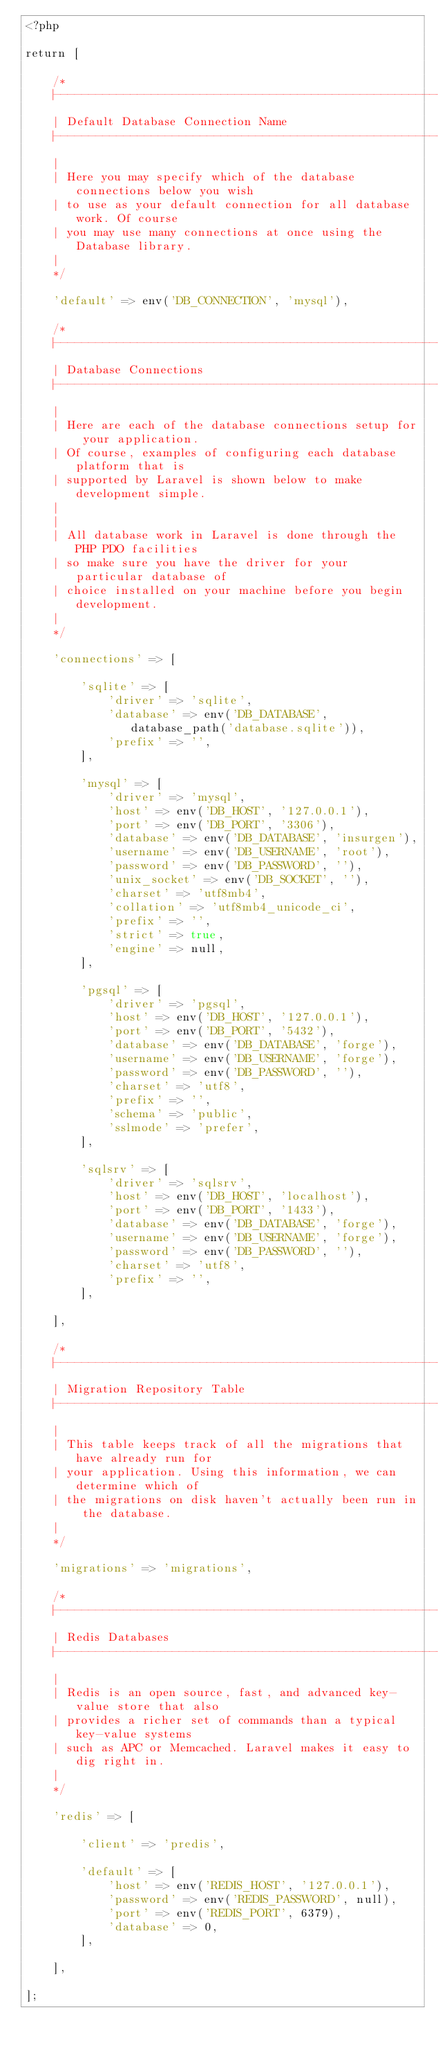Convert code to text. <code><loc_0><loc_0><loc_500><loc_500><_PHP_><?php

return [

    /*
    |--------------------------------------------------------------------------
    | Default Database Connection Name
    |--------------------------------------------------------------------------
    |
    | Here you may specify which of the database connections below you wish
    | to use as your default connection for all database work. Of course
    | you may use many connections at once using the Database library.
    |
    */

    'default' => env('DB_CONNECTION', 'mysql'),

    /*
    |--------------------------------------------------------------------------
    | Database Connections
    |--------------------------------------------------------------------------
    |
    | Here are each of the database connections setup for your application.
    | Of course, examples of configuring each database platform that is
    | supported by Laravel is shown below to make development simple.
    |
    |
    | All database work in Laravel is done through the PHP PDO facilities
    | so make sure you have the driver for your particular database of
    | choice installed on your machine before you begin development.
    |
    */

    'connections' => [

        'sqlite' => [
            'driver' => 'sqlite',
            'database' => env('DB_DATABASE', database_path('database.sqlite')),
            'prefix' => '',
        ],

        'mysql' => [
            'driver' => 'mysql',
            'host' => env('DB_HOST', '127.0.0.1'),
            'port' => env('DB_PORT', '3306'),
            'database' => env('DB_DATABASE', 'insurgen'),
            'username' => env('DB_USERNAME', 'root'),
            'password' => env('DB_PASSWORD', ''),
            'unix_socket' => env('DB_SOCKET', ''),
            'charset' => 'utf8mb4',
            'collation' => 'utf8mb4_unicode_ci',
            'prefix' => '',
            'strict' => true,
            'engine' => null,
        ],

        'pgsql' => [
            'driver' => 'pgsql',
            'host' => env('DB_HOST', '127.0.0.1'),
            'port' => env('DB_PORT', '5432'),
            'database' => env('DB_DATABASE', 'forge'),
            'username' => env('DB_USERNAME', 'forge'),
            'password' => env('DB_PASSWORD', ''),
            'charset' => 'utf8',
            'prefix' => '',
            'schema' => 'public',
            'sslmode' => 'prefer',
        ],

        'sqlsrv' => [
            'driver' => 'sqlsrv',
            'host' => env('DB_HOST', 'localhost'),
            'port' => env('DB_PORT', '1433'),
            'database' => env('DB_DATABASE', 'forge'),
            'username' => env('DB_USERNAME', 'forge'),
            'password' => env('DB_PASSWORD', ''),
            'charset' => 'utf8',
            'prefix' => '',
        ],

    ],

    /*
    |--------------------------------------------------------------------------
    | Migration Repository Table
    |--------------------------------------------------------------------------
    |
    | This table keeps track of all the migrations that have already run for
    | your application. Using this information, we can determine which of
    | the migrations on disk haven't actually been run in the database.
    |
    */

    'migrations' => 'migrations',

    /*
    |--------------------------------------------------------------------------
    | Redis Databases
    |--------------------------------------------------------------------------
    |
    | Redis is an open source, fast, and advanced key-value store that also
    | provides a richer set of commands than a typical key-value systems
    | such as APC or Memcached. Laravel makes it easy to dig right in.
    |
    */

    'redis' => [

        'client' => 'predis',

        'default' => [
            'host' => env('REDIS_HOST', '127.0.0.1'),
            'password' => env('REDIS_PASSWORD', null),
            'port' => env('REDIS_PORT', 6379),
            'database' => 0,
        ],

    ],

];
</code> 